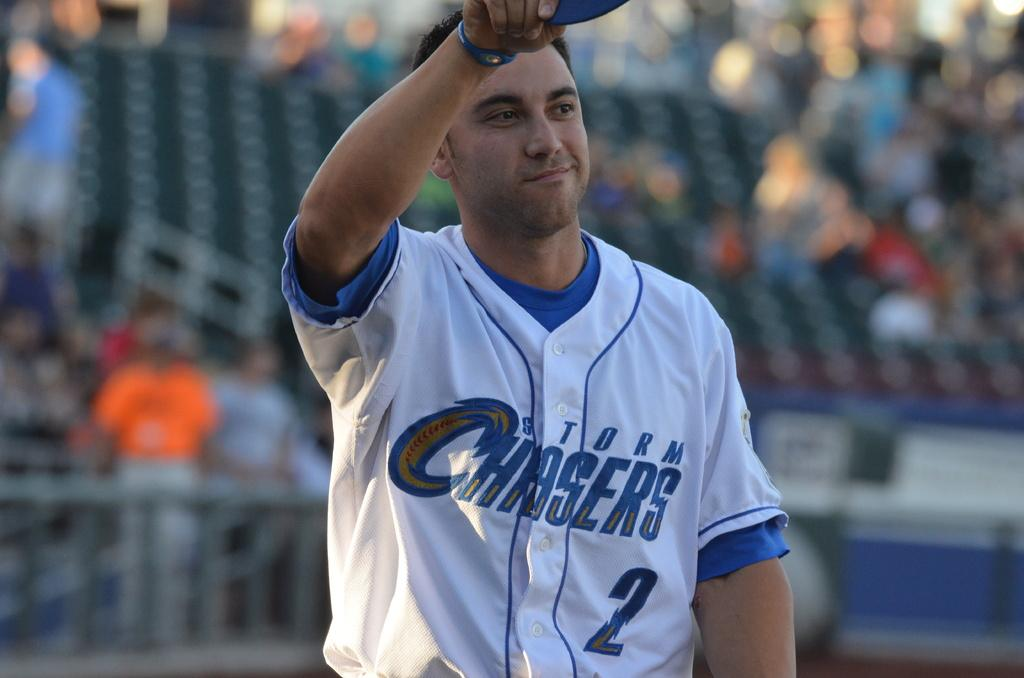<image>
Summarize the visual content of the image. Baseball player for the Chaser team is out on the field 